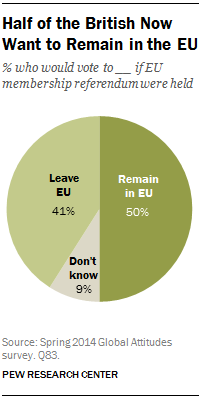Highlight a few significant elements in this photo. A small percentage of British people currently wish to remain in the EU. According to a recent survey, 0.41% of people are willing to leave the EU. 